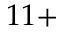Convert formula to latex. <formula><loc_0><loc_0><loc_500><loc_500>1 1 +</formula> 